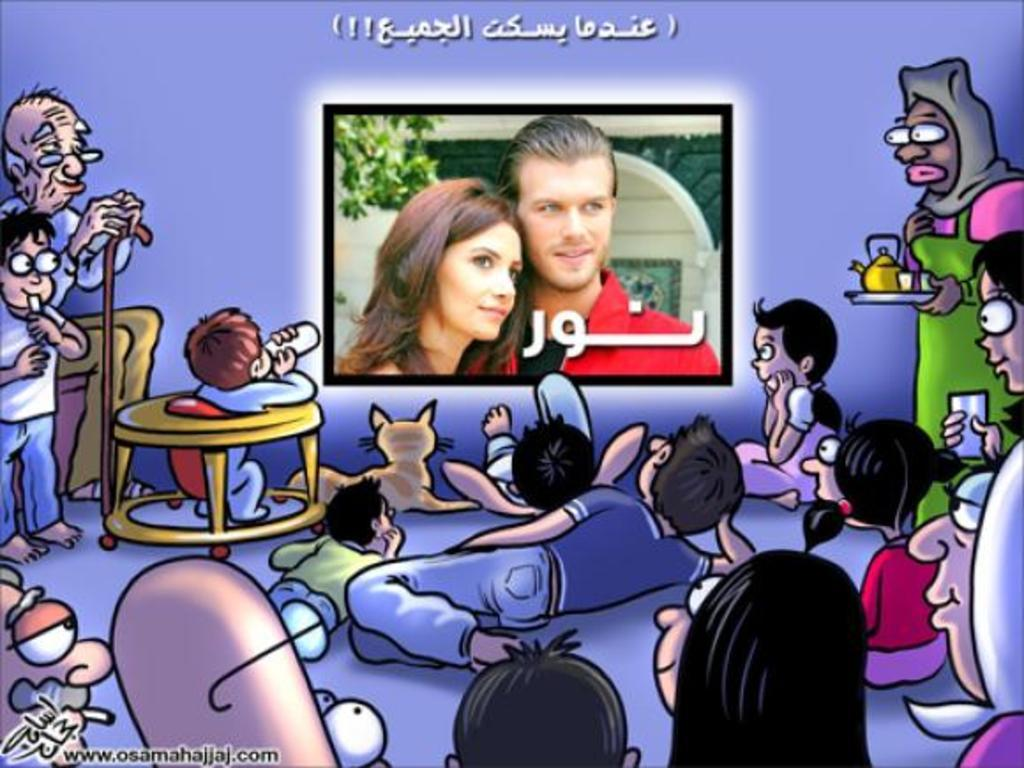What type of image is in the picture? There is a cartoon image in the picture. What is happening in the cartoon image? There are people depicted in the cartoon image. What is one object that can be seen in the cartoon image? There is a screen depicted in the cartoon image. What else is present in the cartoon image besides people and objects? There is text present in the cartoon image. What type of vest can be seen on the snail in the image? There is no snail or vest present in the image; it is a cartoon image with people, objects, and text. 